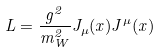<formula> <loc_0><loc_0><loc_500><loc_500>L = \frac { g ^ { 2 } } { m _ { W } ^ { 2 } } J _ { \mu } ( x ) J ^ { \mu } ( x )</formula> 